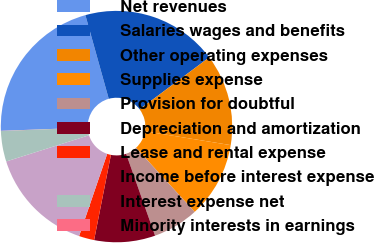<chart> <loc_0><loc_0><loc_500><loc_500><pie_chart><fcel>Net revenues<fcel>Salaries wages and benefits<fcel>Other operating expenses<fcel>Supplies expense<fcel>Provision for doubtful<fcel>Depreciation and amortization<fcel>Lease and rental expense<fcel>Income before interest expense<fcel>Interest expense net<fcel>Minority interests in earnings<nl><fcel>21.25%<fcel>19.13%<fcel>12.76%<fcel>10.64%<fcel>6.39%<fcel>8.51%<fcel>2.14%<fcel>14.88%<fcel>4.27%<fcel>0.02%<nl></chart> 